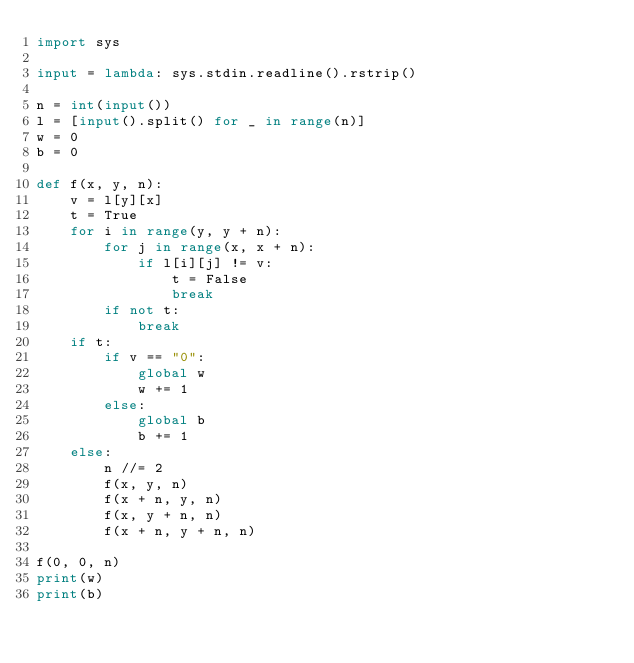Convert code to text. <code><loc_0><loc_0><loc_500><loc_500><_Python_>import sys

input = lambda: sys.stdin.readline().rstrip()

n = int(input())
l = [input().split() for _ in range(n)]
w = 0
b = 0

def f(x, y, n):
    v = l[y][x]
    t = True
    for i in range(y, y + n):
        for j in range(x, x + n):
            if l[i][j] != v:
                t = False
                break
        if not t:
            break
    if t:
        if v == "0":
            global w
            w += 1
        else:
            global b
            b += 1
    else:
        n //= 2
        f(x, y, n)
        f(x + n, y, n)
        f(x, y + n, n)
        f(x + n, y + n, n)

f(0, 0, n)
print(w)
print(b)</code> 